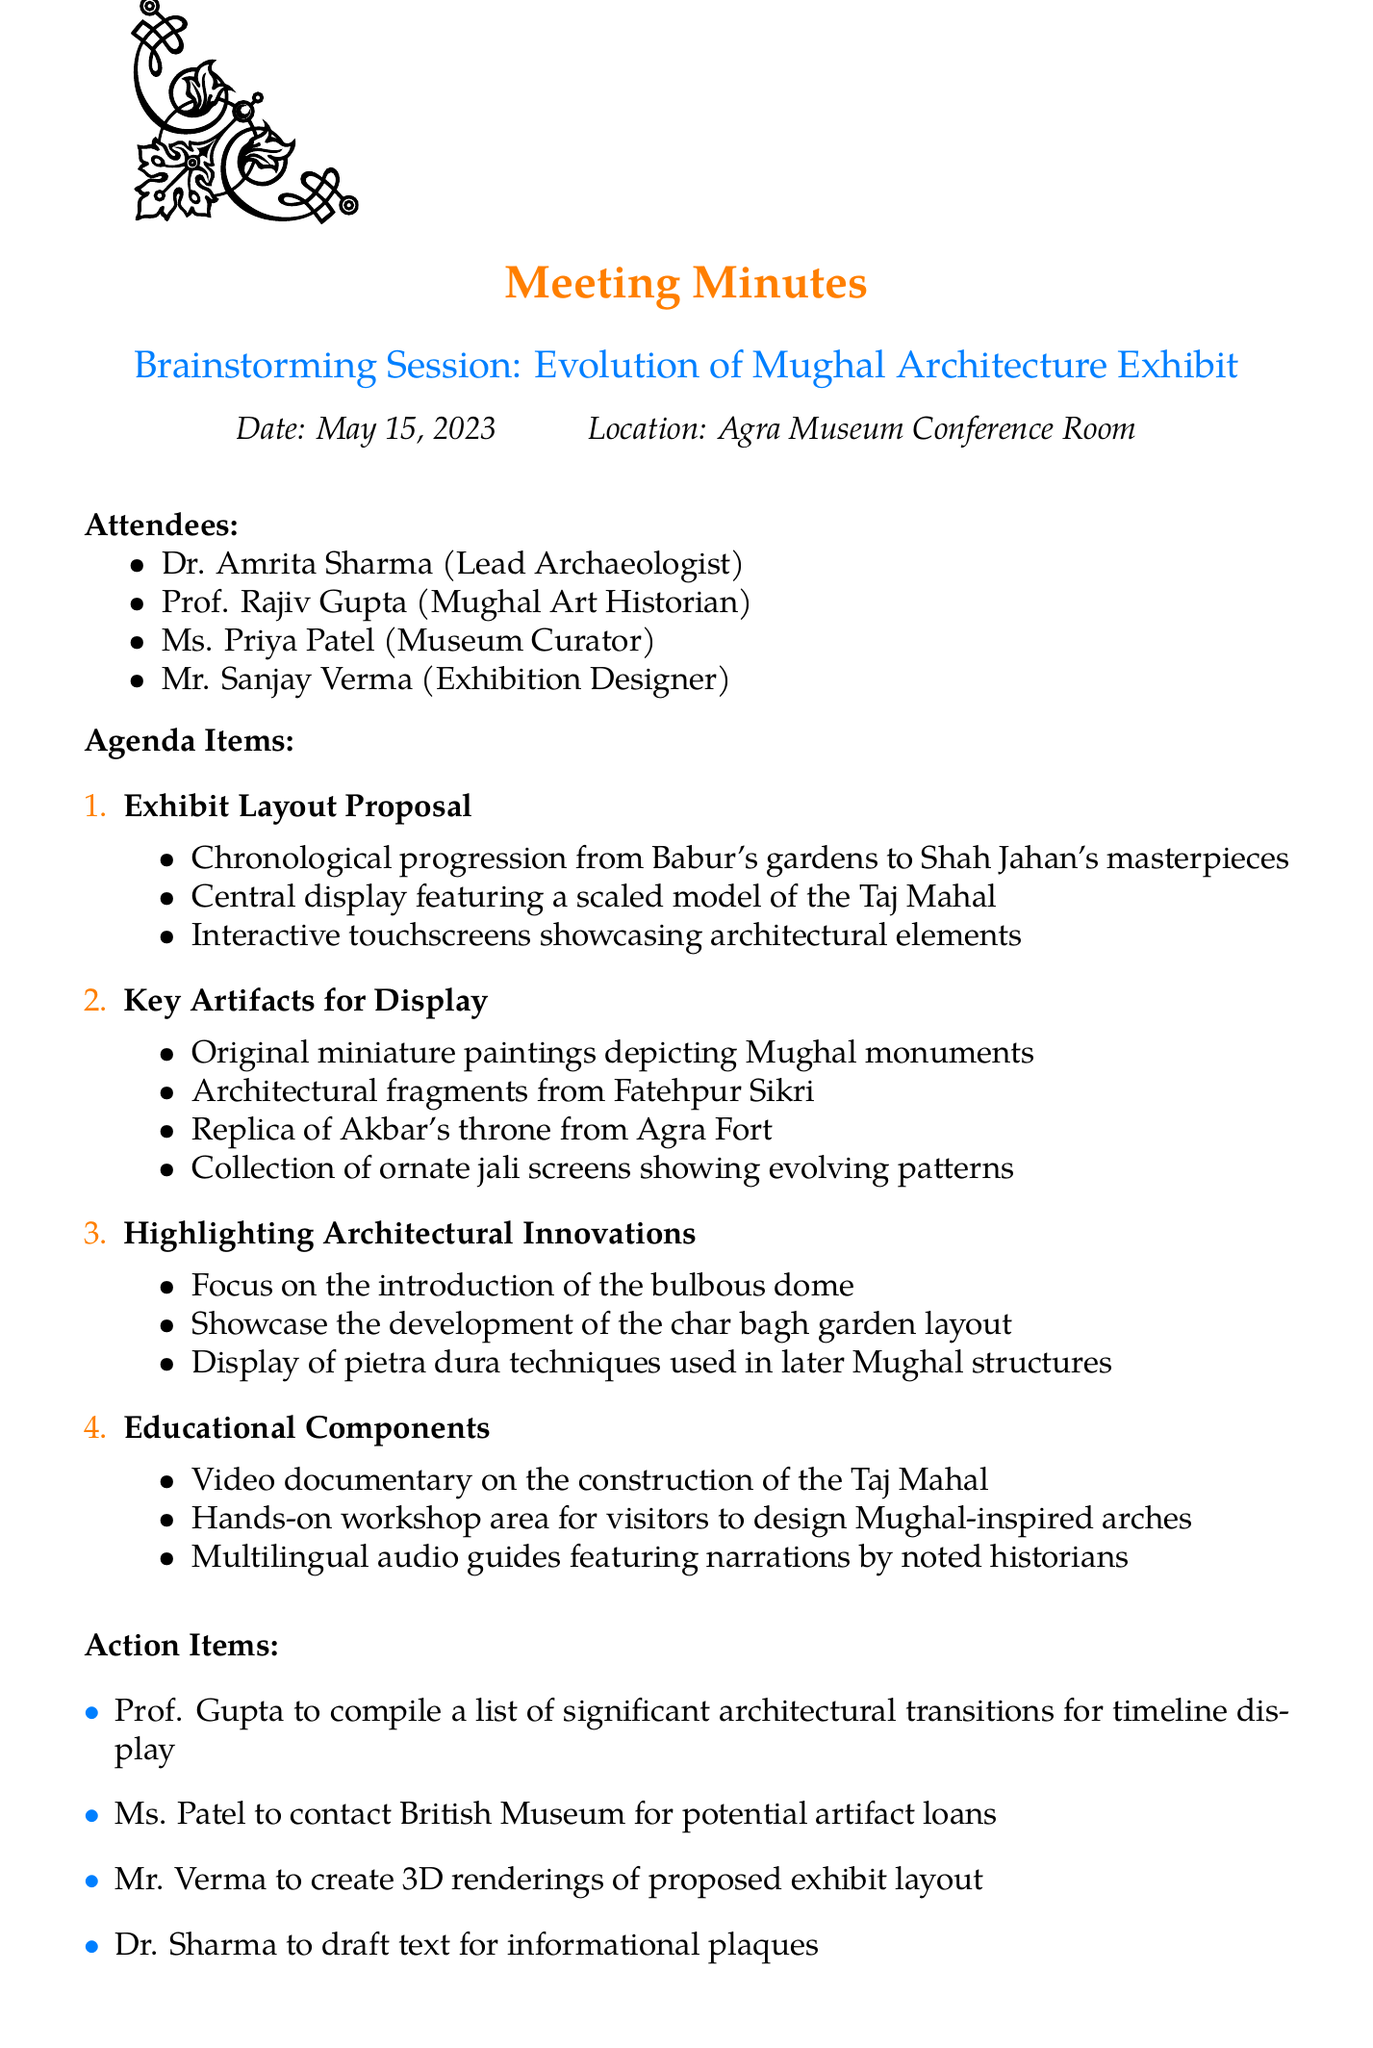What is the date of the meeting? The date of the meeting is explicitly stated in the document as May 15, 2023.
Answer: May 15, 2023 Who is the lead archaeologist attending the meeting? The document lists attendees, and Dr. Amrita Sharma is specifically mentioned as the Lead Archaeologist.
Answer: Dr. Amrita Sharma What is one key artifact proposed for display? The document provides a list under "Key Artifacts for Display," one of which is the original miniature paintings depicting Mughal monuments.
Answer: Original miniature paintings What is the main focus of the educational components discussed? The document outlines various educational components, highlighting a video documentary on the construction of the Taj Mahal as a notable focus.
Answer: Video documentary on the construction of the Taj Mahal Which exhibition designer is handling 3D renderings? An action item specifies Mr. Sanjay Verma is responsible for creating 3D renderings of the proposed exhibit layout.
Answer: Mr. Sanjay Verma How many topics are covered under agenda items? The "Agenda Items" section in the document lists a total of four topics discussed during the meeting.
Answer: Four 